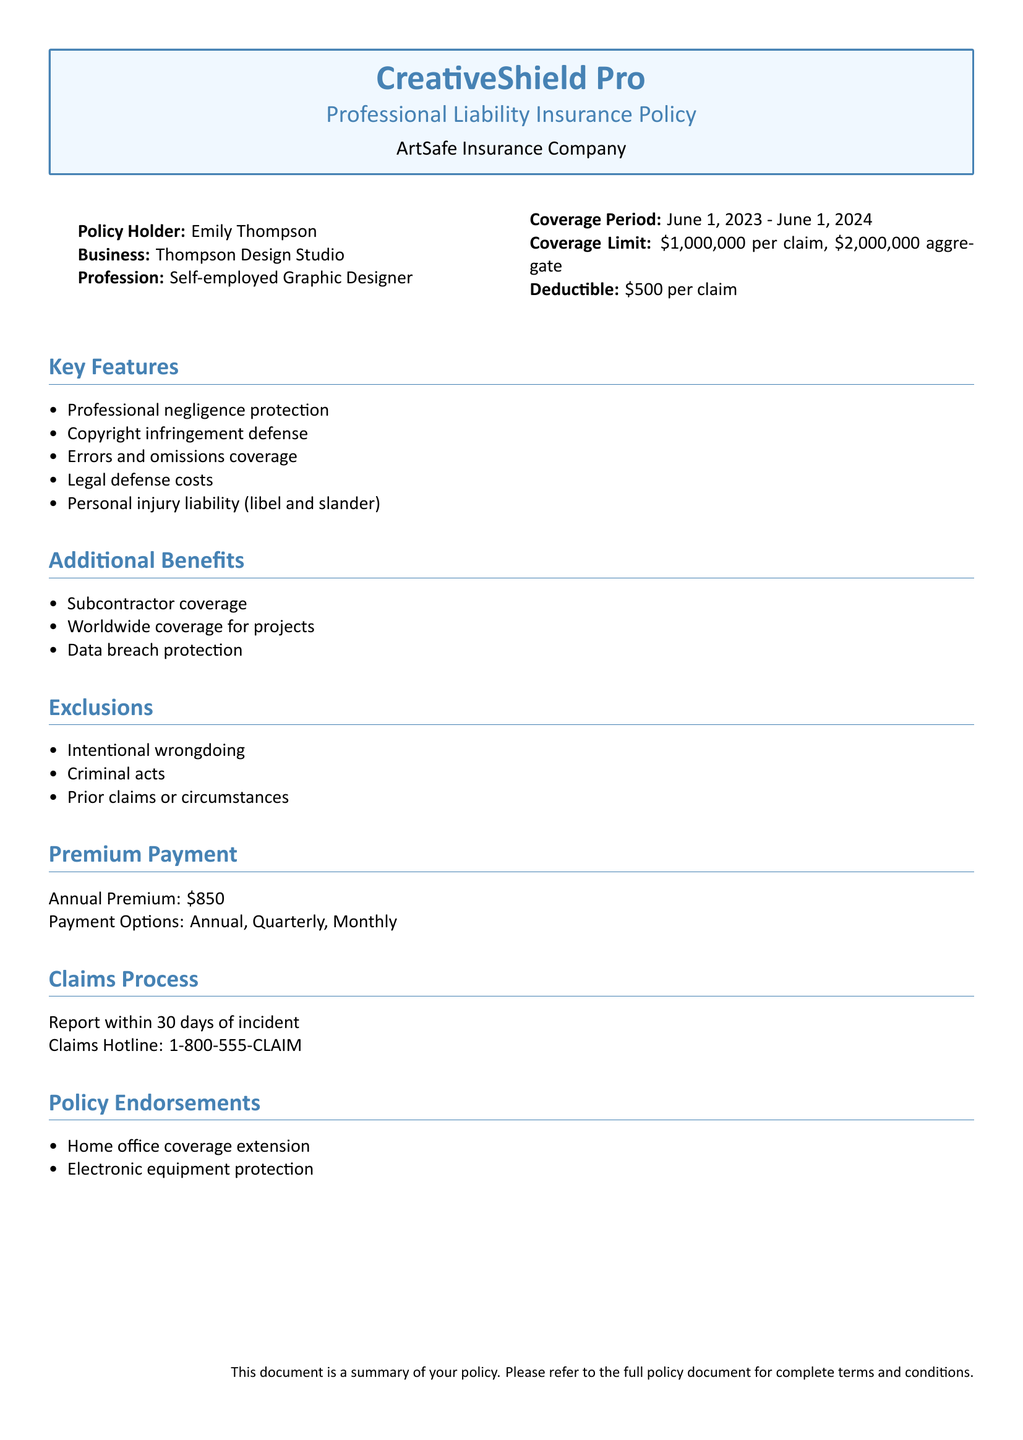What is the name of the insurance company? The name of the insurance company is mentioned in the document header.
Answer: ArtSafe Insurance Company What is the coverage limit for this policy? The coverage limit is specified under the policy details.
Answer: $1,000,000 per claim, $2,000,000 aggregate What is the annual premium for this policy? The annual premium amount is listed under the premium payment section.
Answer: $850 What is the policy holder's profession? The profession of the policy holder is stated in the document.
Answer: Self-employed Graphic Designer What should be done within 30 days of an incident? The claims process section specifies what must be done after an incident.
Answer: Report What is the deductible amount per claim? The deductible is indicated in the policy details.
Answer: $500 Is worldwide coverage provided for projects? The additional benefits section lists various benefits, including this coverage.
Answer: Yes Are there exclusions mentioned in the policy? The exclusions section identifies specific actions that are not covered.
Answer: Yes What type of coverage expansion is included in policy endorsements? The policy endorsements section specifies additional coverage details.
Answer: Home office coverage extension 